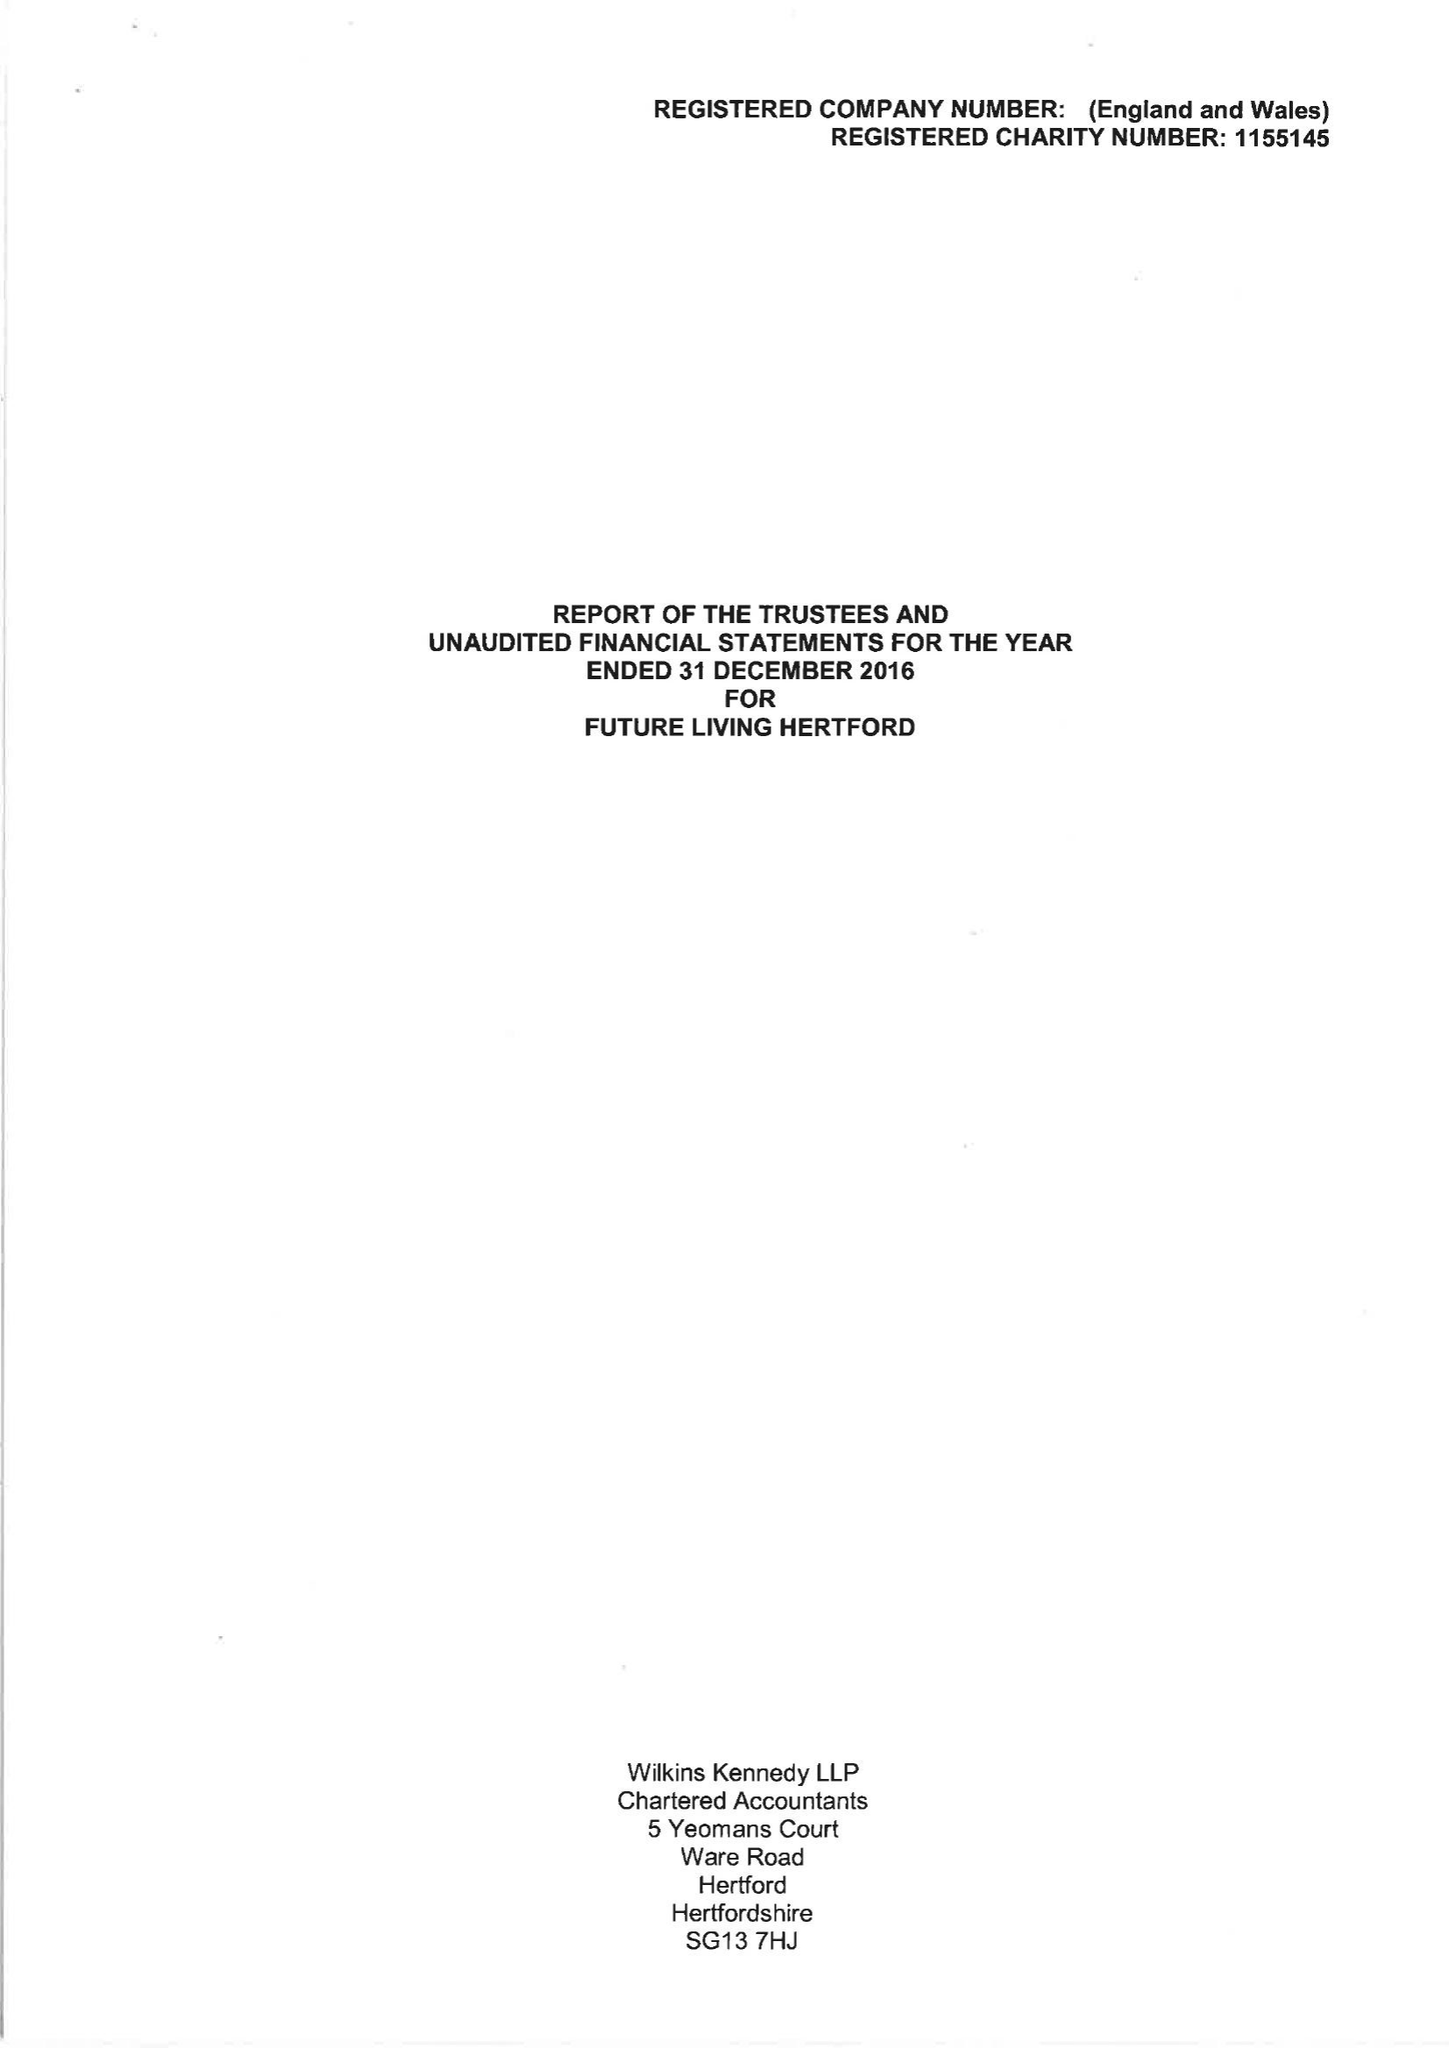What is the value for the spending_annually_in_british_pounds?
Answer the question using a single word or phrase. 48829.00 